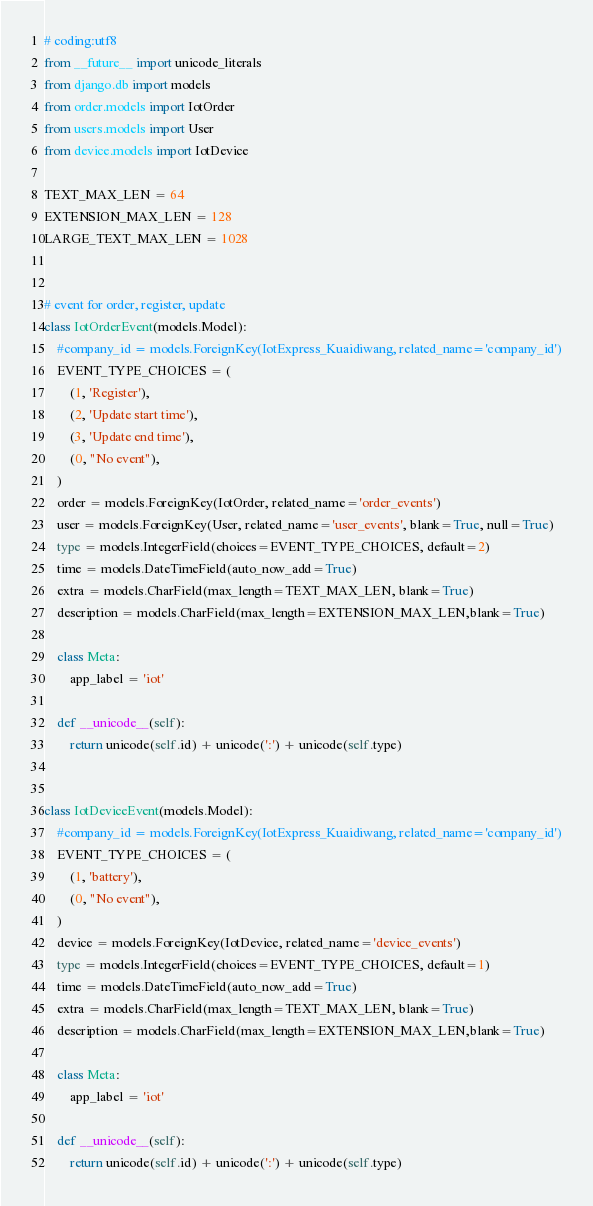Convert code to text. <code><loc_0><loc_0><loc_500><loc_500><_Python_># coding:utf8
from __future__ import unicode_literals
from django.db import models
from order.models import IotOrder
from users.models import User
from device.models import IotDevice

TEXT_MAX_LEN = 64
EXTENSION_MAX_LEN = 128
LARGE_TEXT_MAX_LEN = 1028


# event for order, register, update
class IotOrderEvent(models.Model):
	#company_id = models.ForeignKey(IotExpress_Kuaidiwang, related_name='company_id')
    EVENT_TYPE_CHOICES = (
        (1, 'Register'),
        (2, 'Update start time'),
        (3, 'Update end time'),
        (0, "No event"),
    )
    order = models.ForeignKey(IotOrder, related_name='order_events')
    user = models.ForeignKey(User, related_name='user_events', blank=True, null=True)
    type = models.IntegerField(choices=EVENT_TYPE_CHOICES, default=2)
    time = models.DateTimeField(auto_now_add=True)
    extra = models.CharField(max_length=TEXT_MAX_LEN, blank=True)
    description = models.CharField(max_length=EXTENSION_MAX_LEN,blank=True)

    class Meta:
        app_label = 'iot'

    def __unicode__(self):
        return unicode(self.id) + unicode(':') + unicode(self.type)


class IotDeviceEvent(models.Model):
	#company_id = models.ForeignKey(IotExpress_Kuaidiwang, related_name='company_id')
    EVENT_TYPE_CHOICES = (
        (1, 'battery'),
        (0, "No event"),
    )
    device = models.ForeignKey(IotDevice, related_name='device_events')
    type = models.IntegerField(choices=EVENT_TYPE_CHOICES, default=1)
    time = models.DateTimeField(auto_now_add=True)
    extra = models.CharField(max_length=TEXT_MAX_LEN, blank=True)
    description = models.CharField(max_length=EXTENSION_MAX_LEN,blank=True)

    class Meta:
        app_label = 'iot'

    def __unicode__(self):
        return unicode(self.id) + unicode(':') + unicode(self.type)</code> 